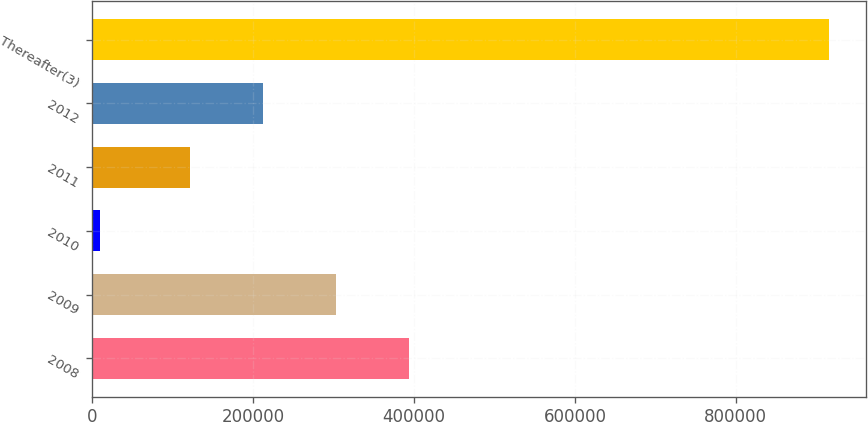Convert chart to OTSL. <chart><loc_0><loc_0><loc_500><loc_500><bar_chart><fcel>2008<fcel>2009<fcel>2010<fcel>2011<fcel>2012<fcel>Thereafter(3)<nl><fcel>393503<fcel>302784<fcel>8924<fcel>121348<fcel>212066<fcel>916106<nl></chart> 